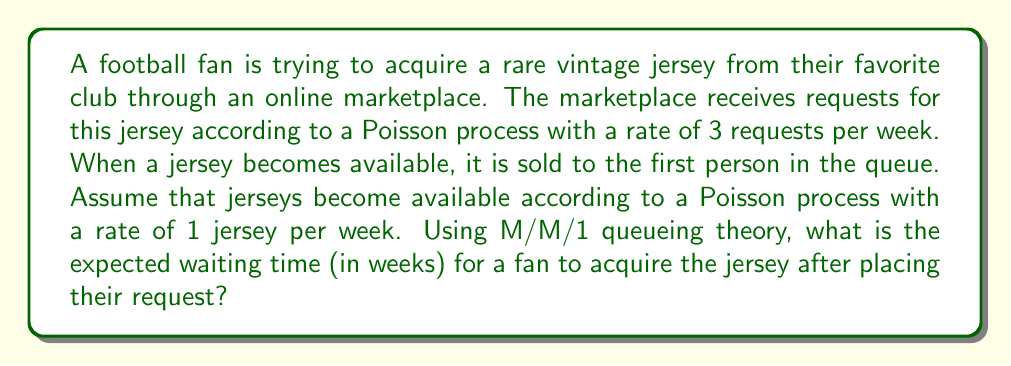Solve this math problem. To solve this problem, we'll use the M/M/1 queueing model:

1) First, identify the parameters:
   $\lambda$ = arrival rate = 3 requests/week
   $\mu$ = service rate = 1 jersey/week

2) Calculate the utilization factor $\rho$:
   $$\rho = \frac{\lambda}{\mu} = \frac{3}{1} = 3$$

3) The expected number of customers in the system (including the one being served) is given by:
   $$L = \frac{\rho}{1-\rho} = \frac{3}{1-3} = -\frac{3}{2}$$

4) The expected waiting time in the system (including service time) is given by Little's Law:
   $$W = \frac{L}{\lambda} = \frac{-\frac{3}{2}}{3} = -\frac{1}{2}$$

5) However, the negative values for L and W indicate that the system is unstable (more requests are coming in than can be served). In this case, the queue will grow indefinitely, and the expected waiting time approaches infinity.

6) For an unstable system, we cannot calculate a finite expected waiting time. The demand for jerseys exceeds the supply, so fans can expect to wait indefinitely.
Answer: The expected waiting time is infinite. 